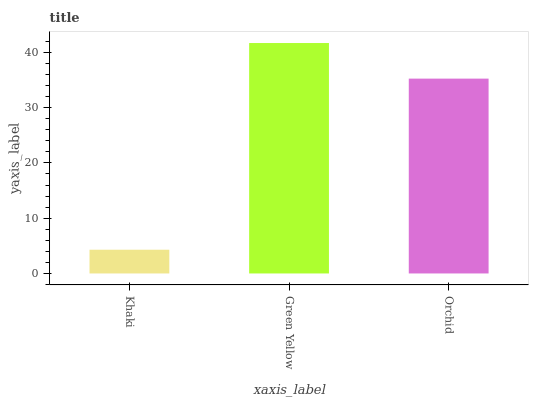Is Khaki the minimum?
Answer yes or no. Yes. Is Green Yellow the maximum?
Answer yes or no. Yes. Is Orchid the minimum?
Answer yes or no. No. Is Orchid the maximum?
Answer yes or no. No. Is Green Yellow greater than Orchid?
Answer yes or no. Yes. Is Orchid less than Green Yellow?
Answer yes or no. Yes. Is Orchid greater than Green Yellow?
Answer yes or no. No. Is Green Yellow less than Orchid?
Answer yes or no. No. Is Orchid the high median?
Answer yes or no. Yes. Is Orchid the low median?
Answer yes or no. Yes. Is Khaki the high median?
Answer yes or no. No. Is Green Yellow the low median?
Answer yes or no. No. 